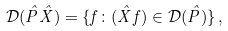Convert formula to latex. <formula><loc_0><loc_0><loc_500><loc_500>\mathcal { D } ( \hat { P } \hat { X } ) = \{ f \colon ( \hat { X } f ) \in \mathcal { D } ( \hat { P } ) \} \, ,</formula> 